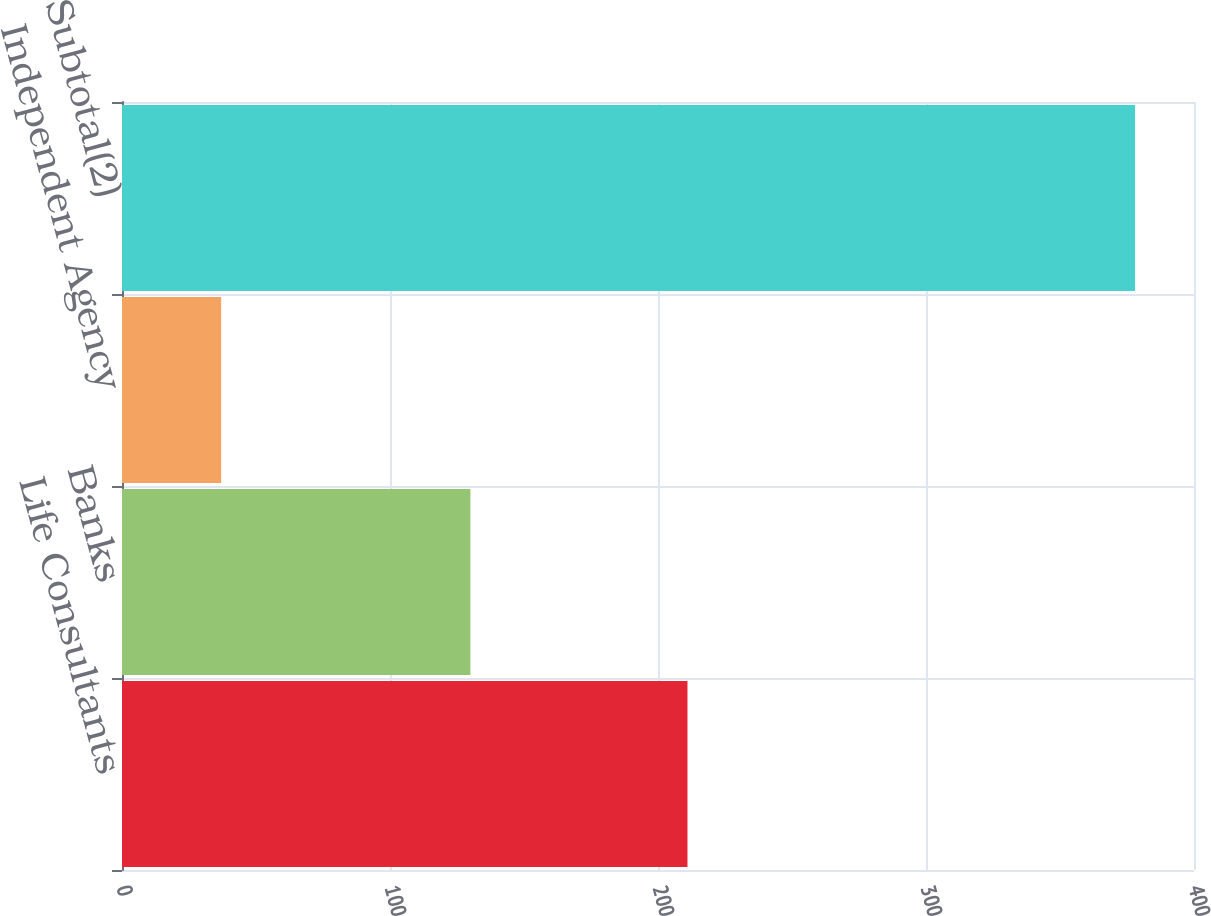Convert chart. <chart><loc_0><loc_0><loc_500><loc_500><bar_chart><fcel>Life Consultants<fcel>Banks<fcel>Independent Agency<fcel>Subtotal(2)<nl><fcel>211<fcel>130<fcel>37<fcel>378<nl></chart> 